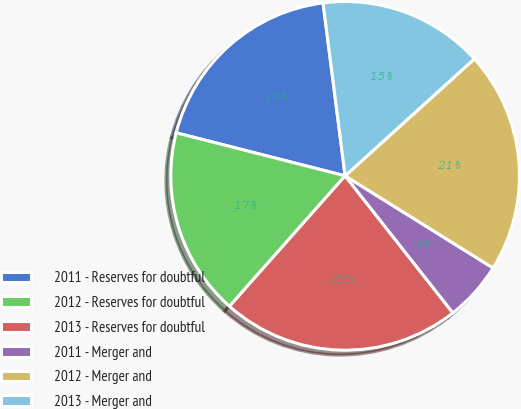Convert chart to OTSL. <chart><loc_0><loc_0><loc_500><loc_500><pie_chart><fcel>2011 - Reserves for doubtful<fcel>2012 - Reserves for doubtful<fcel>2013 - Reserves for doubtful<fcel>2011 - Merger and<fcel>2012 - Merger and<fcel>2013 - Merger and<nl><fcel>19.01%<fcel>17.43%<fcel>22.15%<fcel>5.53%<fcel>20.58%<fcel>15.31%<nl></chart> 